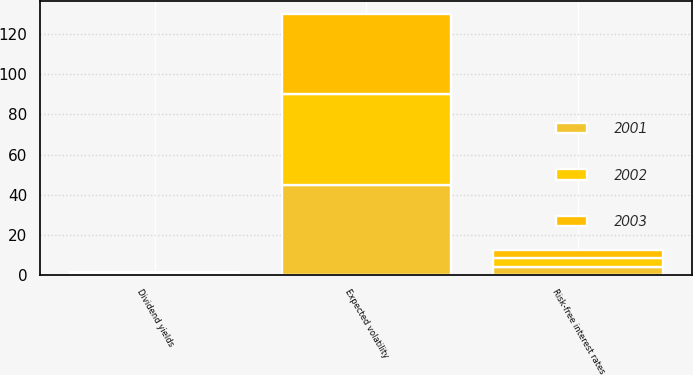Convert chart to OTSL. <chart><loc_0><loc_0><loc_500><loc_500><stacked_bar_chart><ecel><fcel>Risk-free interest rates<fcel>Expected volatility<fcel>Dividend yields<nl><fcel>2003<fcel>3.75<fcel>40<fcel>0.6<nl><fcel>2001<fcel>3.75<fcel>45<fcel>0.8<nl><fcel>2002<fcel>4.68<fcel>45<fcel>0<nl></chart> 